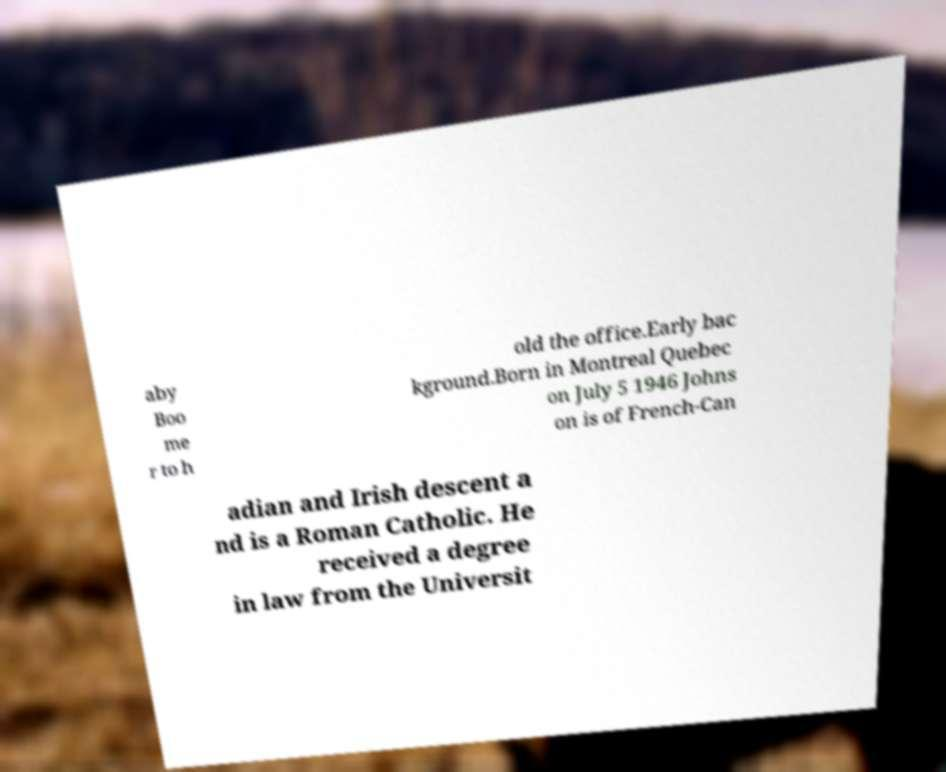Can you read and provide the text displayed in the image?This photo seems to have some interesting text. Can you extract and type it out for me? aby Boo me r to h old the office.Early bac kground.Born in Montreal Quebec on July 5 1946 Johns on is of French-Can adian and Irish descent a nd is a Roman Catholic. He received a degree in law from the Universit 